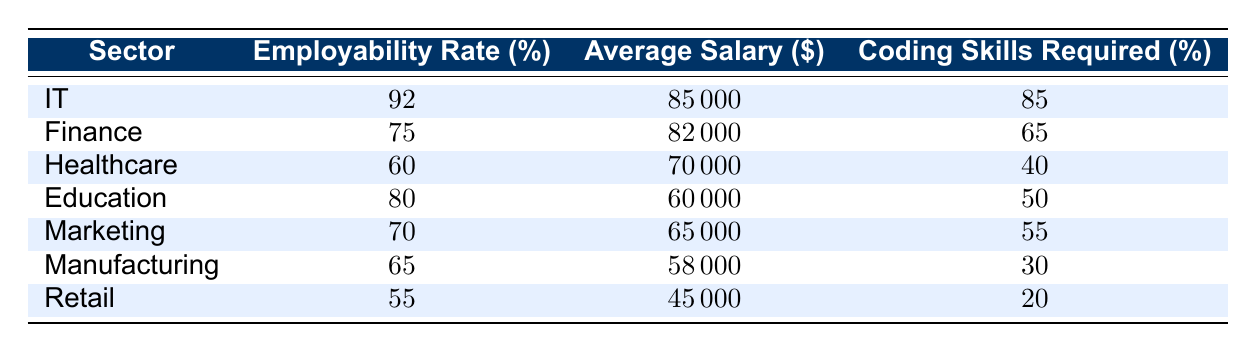What is the employability rate in the IT sector? From the table, the employability rate for the IT sector is directly listed under the "Employability Rate (%)" column. It shows a rate of 92%.
Answer: 92% Which sector has the highest average salary? By examining the "Average Salary ($)" column, we find that the IT sector has the highest average salary at $85,000.
Answer: IT What is the difference in employability rates between Retail and Healthcare? The employability rate for Retail is 55% and for Healthcare is 60%. The difference is calculated as 60% - 55% = 5%.
Answer: 5% Is the average salary in Manufacturing higher than that in Education? Looking at the "Average Salary ($)" column, the average salary for Manufacturing is $58,000, and for Education it is $60,000. Since $58,000 is less than $60,000, the statement is false.
Answer: No What average coding skills are required in Finance and IT combined? The coding skills required are 65% for Finance and 85% for IT. The average is calculated as (65% + 85%) / 2 = 75%.
Answer: 75% Which sector has the lowest employability rate and what is its percentage? From the table, Retail has the lowest employability rate at 55%. This can be confirmed by checking all the employability rates listed.
Answer: Retail, 55% What is the average coding skills required across all sectors listed? The coding skills required for all sectors are 85% (IT), 65% (Finance), 40% (Healthcare), 50% (Education), 55% (Marketing), 30% (Manufacturing), and 20% (Retail). Summing these gives 85 + 65 + 40 + 50 + 55 + 30 + 20 = 345. There are 7 sectors, so the average is 345/7 ≈ 49.29%.
Answer: Approximately 49.29% Is the employability rate for Marketing greater than or equal to 70%? The employability rate for Marketing is 70%. Since 70% is equal to 70%, the statement is true.
Answer: Yes How does the average salary in Healthcare compare to that in Marketing? The average salary in Healthcare is $70,000 and in Marketing is $65,000. Comparing these two values, $70,000 is greater than $65,000. Therefore, Healthcare has a higher average salary.
Answer: Healthcare is higher 